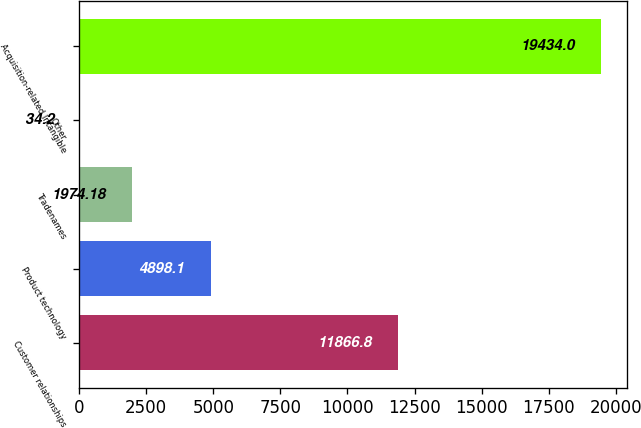Convert chart. <chart><loc_0><loc_0><loc_500><loc_500><bar_chart><fcel>Customer relationships<fcel>Product technology<fcel>Tradenames<fcel>Other<fcel>Acquisition-related Intangible<nl><fcel>11866.8<fcel>4898.1<fcel>1974.18<fcel>34.2<fcel>19434<nl></chart> 